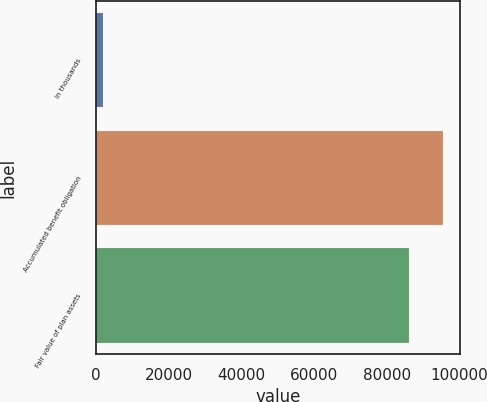<chart> <loc_0><loc_0><loc_500><loc_500><bar_chart><fcel>In thousands<fcel>Accumulated benefit obligation<fcel>Fair value of plan assets<nl><fcel>2011<fcel>95448.4<fcel>86199<nl></chart> 